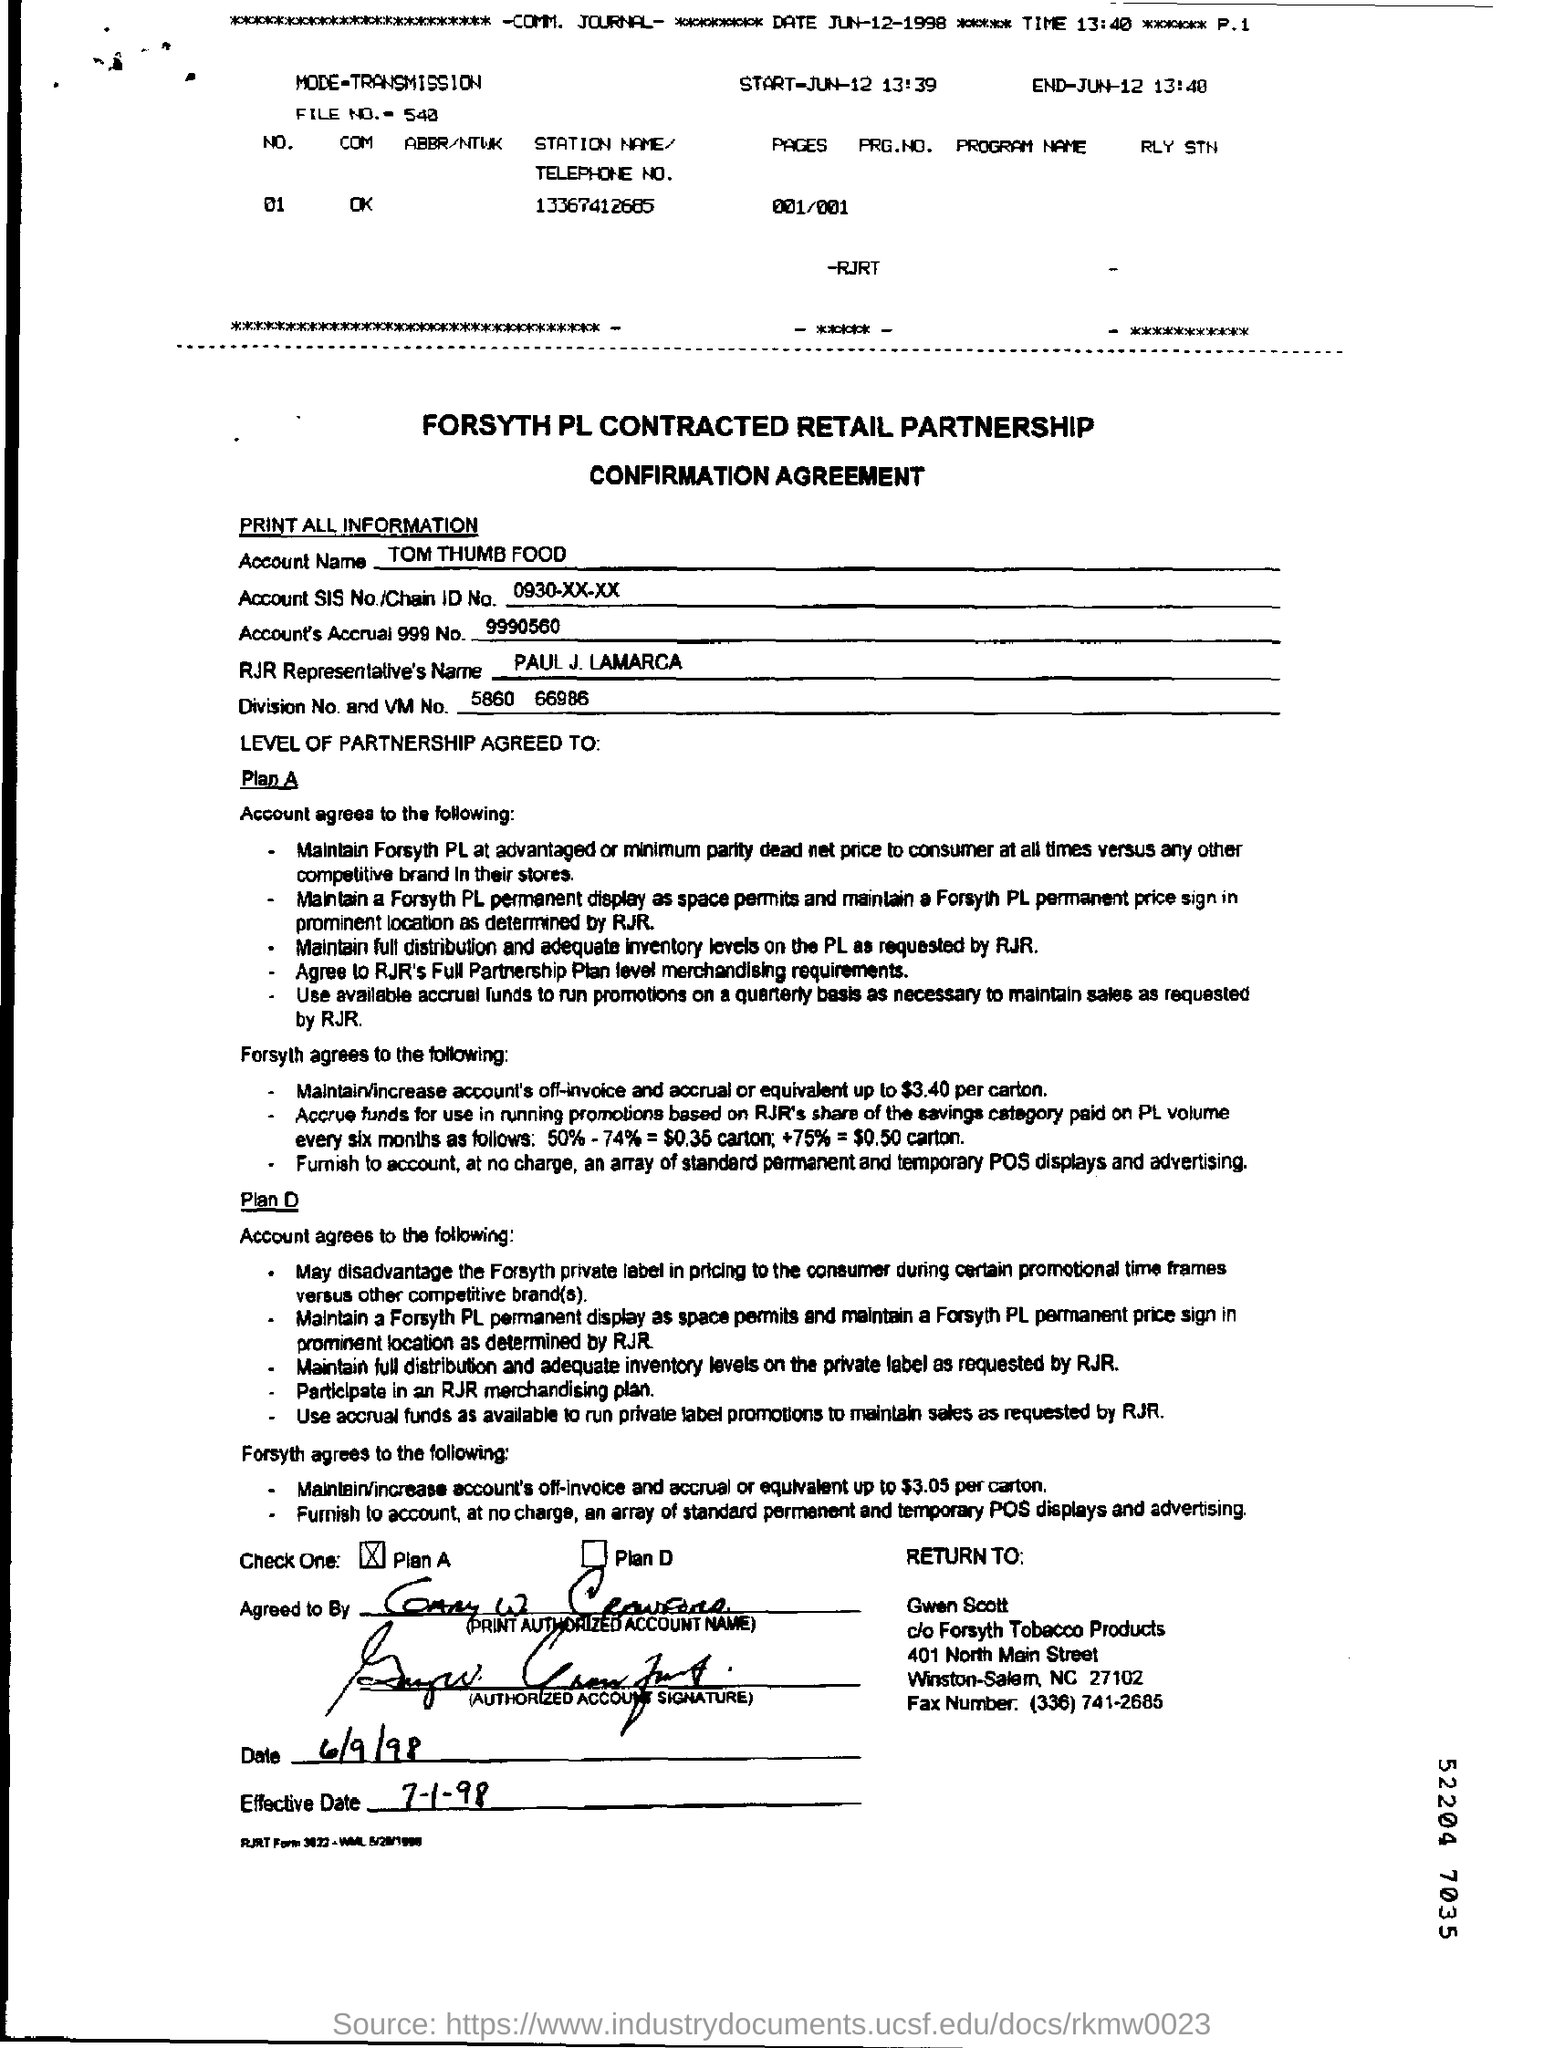Outline some significant characteristics in this image. The account name is TOM THUMB FOOD. What is the account SIS No./Chain ID No.? It is 0930-XX-XX.. The RJR Representative's name is Paul J. Lamarca. 